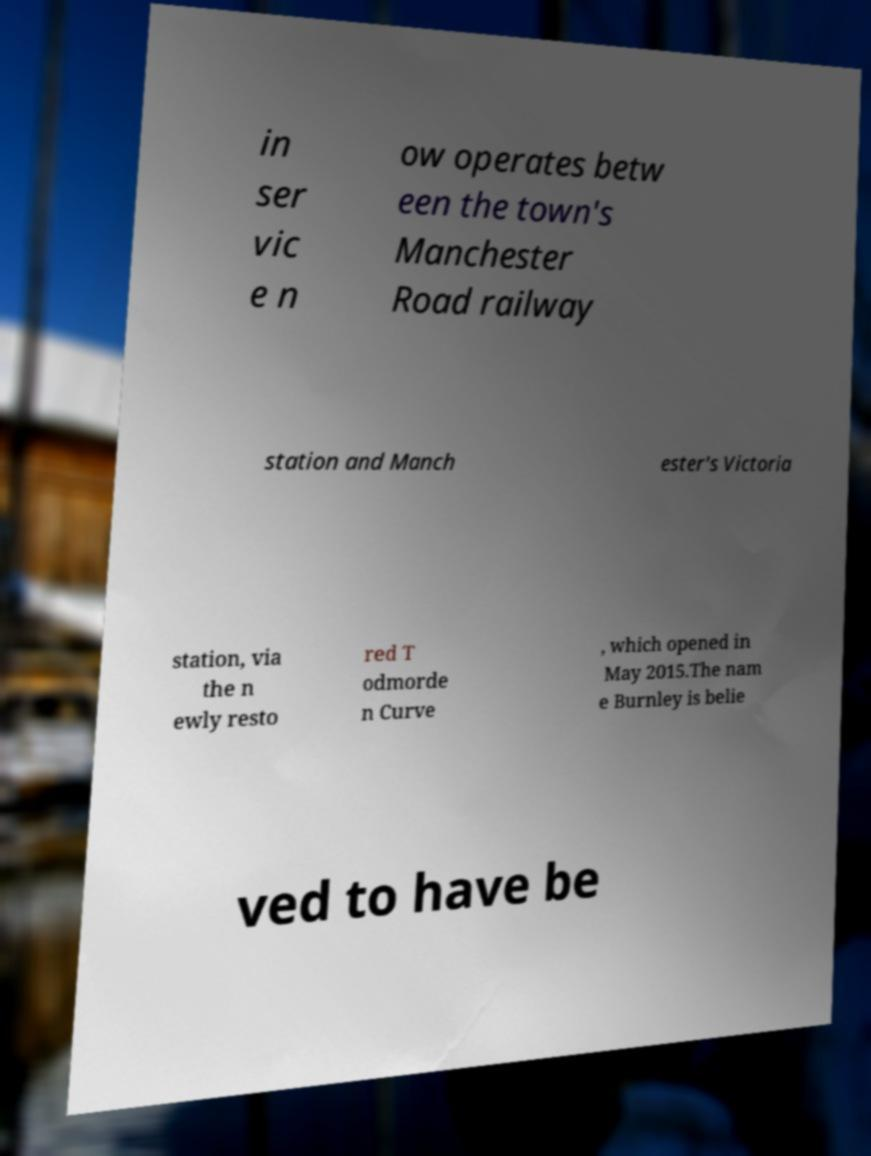There's text embedded in this image that I need extracted. Can you transcribe it verbatim? in ser vic e n ow operates betw een the town's Manchester Road railway station and Manch ester's Victoria station, via the n ewly resto red T odmorde n Curve , which opened in May 2015.The nam e Burnley is belie ved to have be 